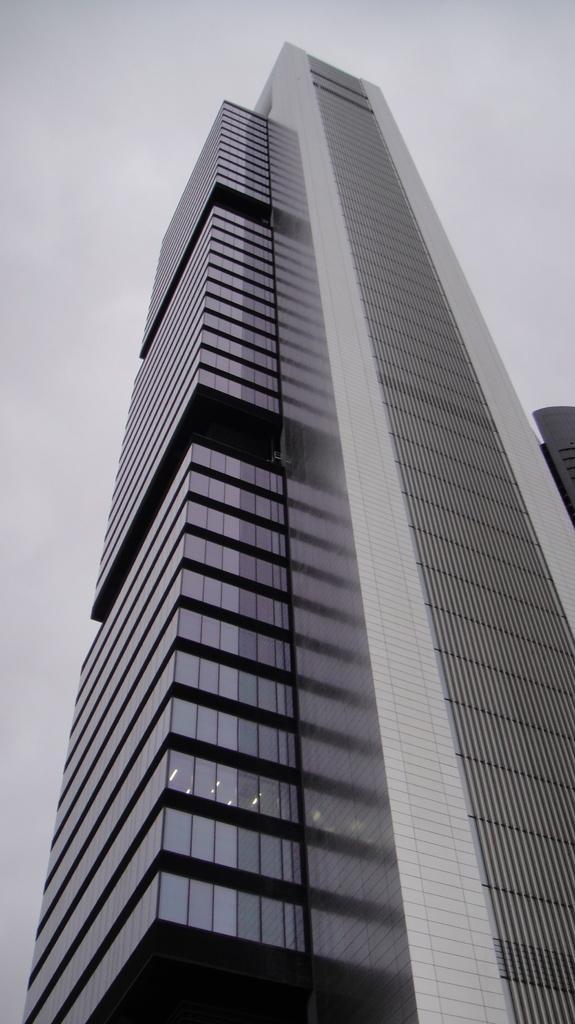Can you describe this image briefly? In this image in the center there is a skyscraper, and at the top there is sky. 